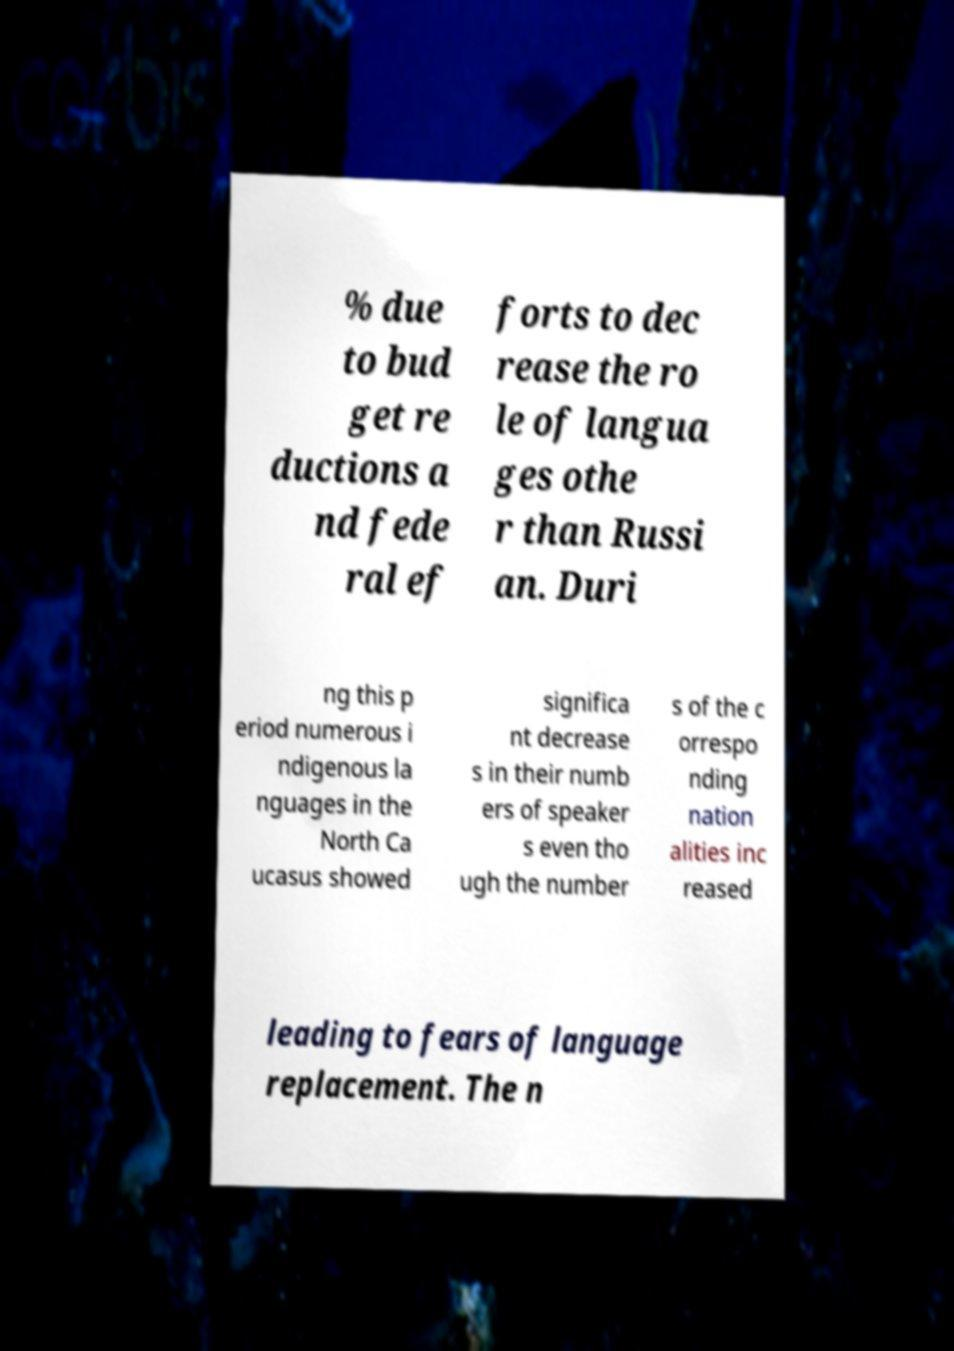I need the written content from this picture converted into text. Can you do that? % due to bud get re ductions a nd fede ral ef forts to dec rease the ro le of langua ges othe r than Russi an. Duri ng this p eriod numerous i ndigenous la nguages in the North Ca ucasus showed significa nt decrease s in their numb ers of speaker s even tho ugh the number s of the c orrespo nding nation alities inc reased leading to fears of language replacement. The n 